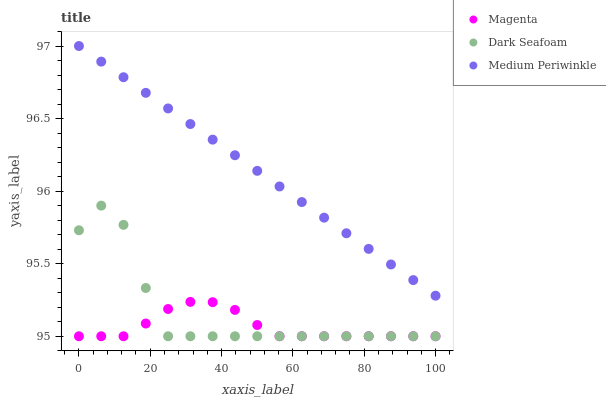Does Magenta have the minimum area under the curve?
Answer yes or no. Yes. Does Medium Periwinkle have the maximum area under the curve?
Answer yes or no. Yes. Does Dark Seafoam have the minimum area under the curve?
Answer yes or no. No. Does Dark Seafoam have the maximum area under the curve?
Answer yes or no. No. Is Medium Periwinkle the smoothest?
Answer yes or no. Yes. Is Dark Seafoam the roughest?
Answer yes or no. Yes. Is Dark Seafoam the smoothest?
Answer yes or no. No. Is Medium Periwinkle the roughest?
Answer yes or no. No. Does Magenta have the lowest value?
Answer yes or no. Yes. Does Medium Periwinkle have the lowest value?
Answer yes or no. No. Does Medium Periwinkle have the highest value?
Answer yes or no. Yes. Does Dark Seafoam have the highest value?
Answer yes or no. No. Is Dark Seafoam less than Medium Periwinkle?
Answer yes or no. Yes. Is Medium Periwinkle greater than Dark Seafoam?
Answer yes or no. Yes. Does Magenta intersect Dark Seafoam?
Answer yes or no. Yes. Is Magenta less than Dark Seafoam?
Answer yes or no. No. Is Magenta greater than Dark Seafoam?
Answer yes or no. No. Does Dark Seafoam intersect Medium Periwinkle?
Answer yes or no. No. 